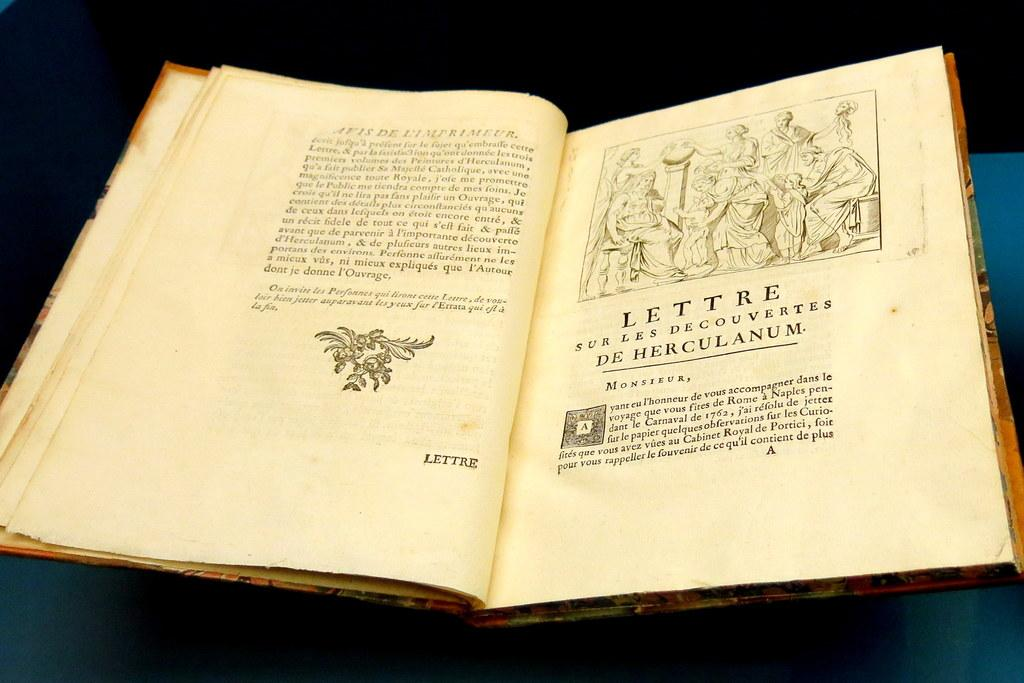Provide a one-sentence caption for the provided image. The letter on the open page of the book is written to Monsieur. 